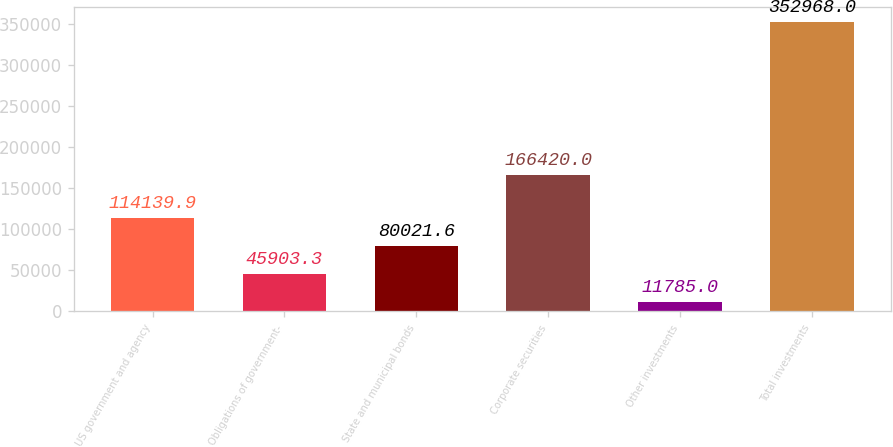<chart> <loc_0><loc_0><loc_500><loc_500><bar_chart><fcel>US government and agency<fcel>Obligations of government-<fcel>State and municipal bonds<fcel>Corporate securities<fcel>Other investments<fcel>Total investments<nl><fcel>114140<fcel>45903.3<fcel>80021.6<fcel>166420<fcel>11785<fcel>352968<nl></chart> 